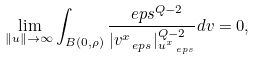Convert formula to latex. <formula><loc_0><loc_0><loc_500><loc_500>\lim _ { \| u \| \to \infty } \int _ { B ( 0 , \rho ) } \frac { \ e p s ^ { Q - 2 } } { | v _ { \ e p s } ^ { x } | _ { u _ { \ e p s } ^ { x } } ^ { Q - 2 } } d v = 0 ,</formula> 